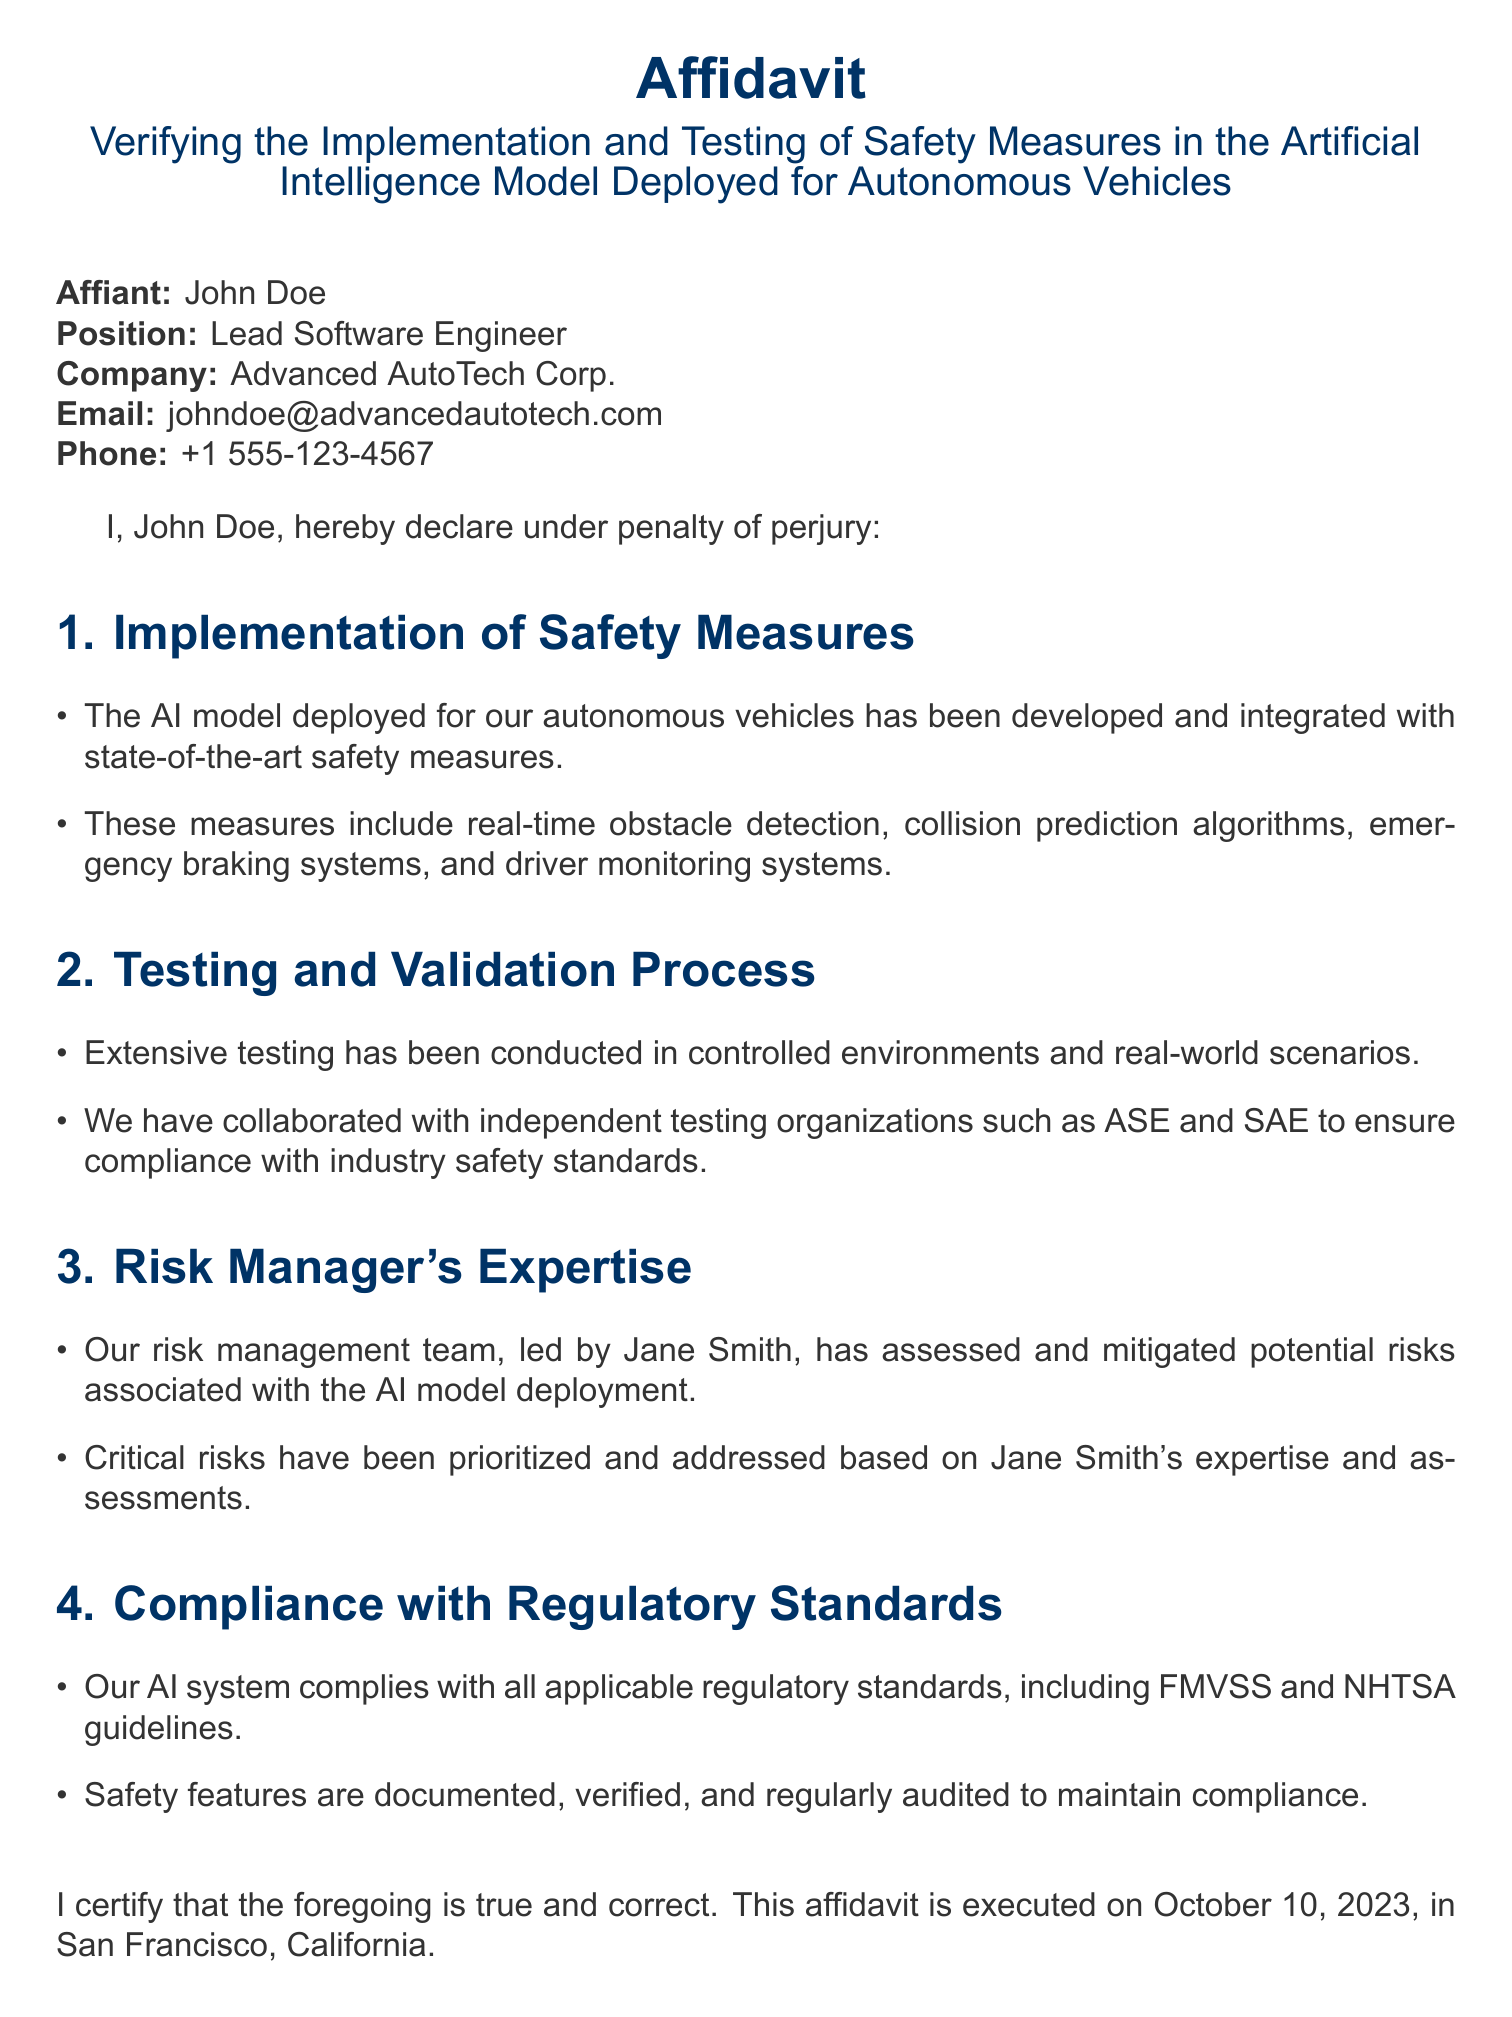What is the name of the affiant? The affiant is the person who swears to the statements in the affidavit, which is John Doe.
Answer: John Doe What is the position of the affiant? The position of the affiant indicates his role at the company, which is Lead Software Engineer.
Answer: Lead Software Engineer What is the name of the risk manager? The risk manager's expertise is crucial to the safety assessment, and her name is Jane Smith.
Answer: Jane Smith On what date was the affidavit executed? The execution date is the date on which the affidavit was formally completed, which is October 10, 2023.
Answer: October 10, 2023 What safety measure is mentioned for emergency situations? The safety measure specifically designed for emergency situations is the emergency braking system.
Answer: emergency braking system Which organizations were collaborated with for testing? Collaboration with independent organizations is stated, and they include ASE and SAE for testing purposes.
Answer: ASE and SAE What regulatory standards does the AI system comply with? The regulatory standards that the AI system complies with are FMVSS and NHTSA guidelines.
Answer: FMVSS and NHTSA How is the compliance of safety features maintained? The compliance is maintained through documentation, verification, and regular audits of the safety features.
Answer: regular audits What type of testing was conducted for the AI model? The testing conducted is specified as extensive testing in both controlled environments and real-world scenarios.
Answer: extensive testing 